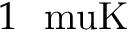Convert formula to latex. <formula><loc_0><loc_0><loc_500><loc_500>1 \ m u K</formula> 